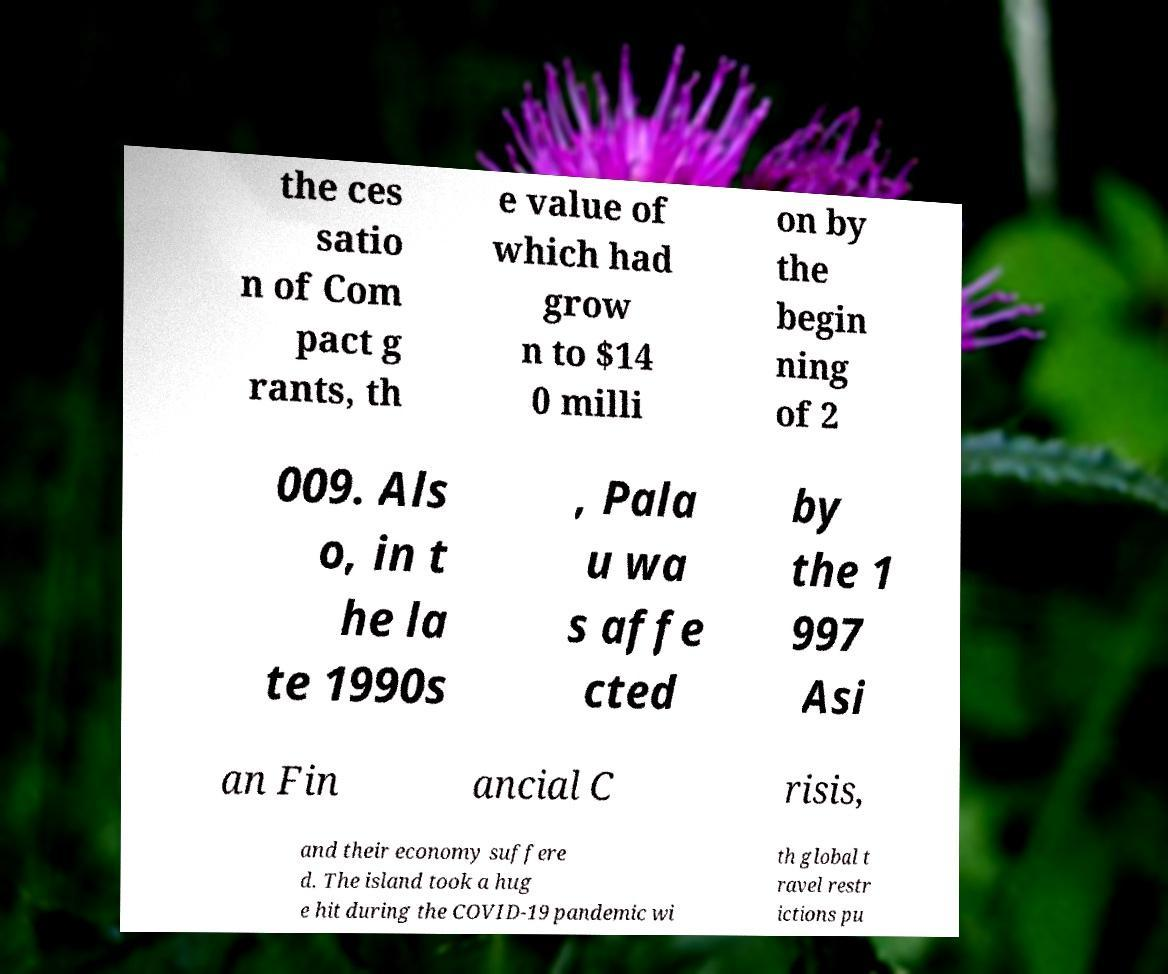I need the written content from this picture converted into text. Can you do that? the ces satio n of Com pact g rants, th e value of which had grow n to $14 0 milli on by the begin ning of 2 009. Als o, in t he la te 1990s , Pala u wa s affe cted by the 1 997 Asi an Fin ancial C risis, and their economy suffere d. The island took a hug e hit during the COVID-19 pandemic wi th global t ravel restr ictions pu 